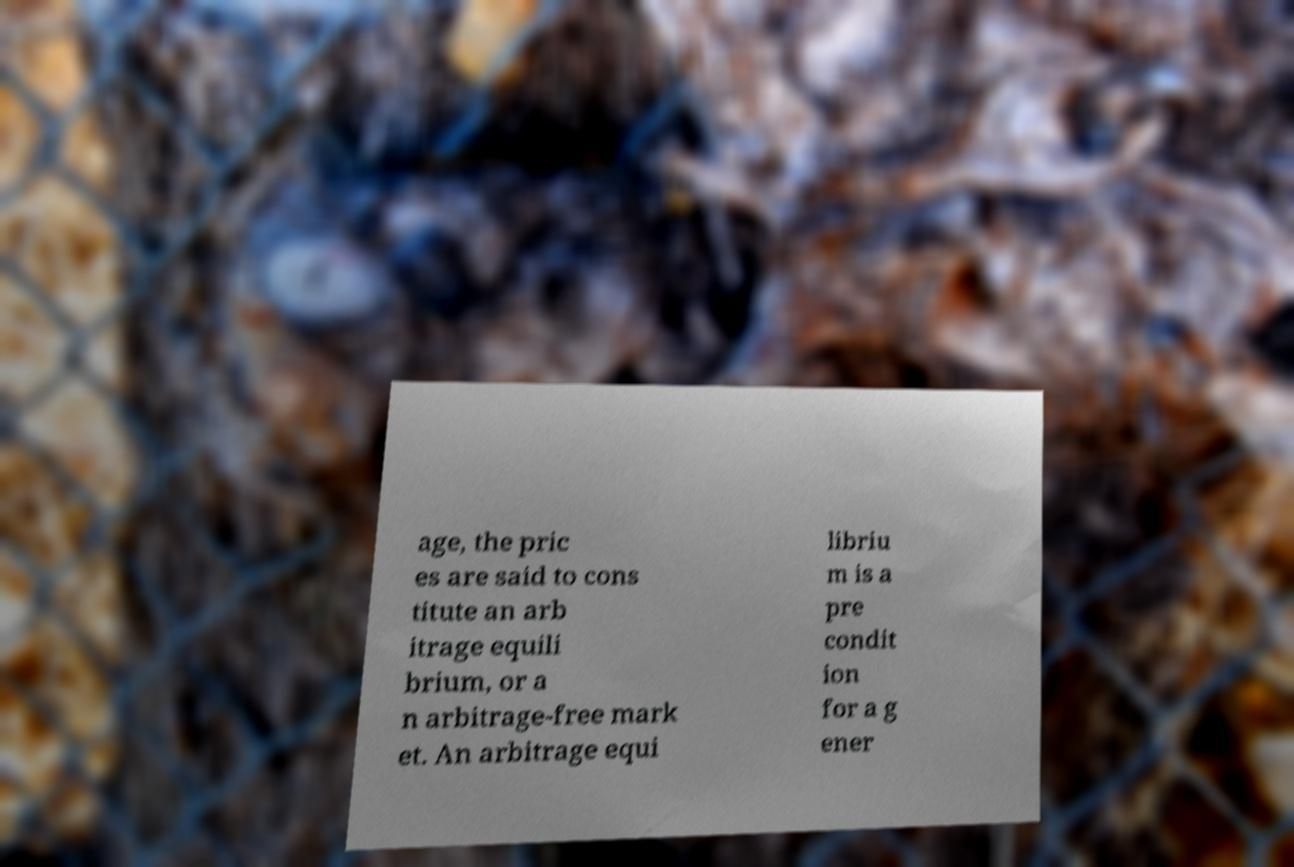Can you read and provide the text displayed in the image?This photo seems to have some interesting text. Can you extract and type it out for me? age, the pric es are said to cons titute an arb itrage equili brium, or a n arbitrage-free mark et. An arbitrage equi libriu m is a pre condit ion for a g ener 